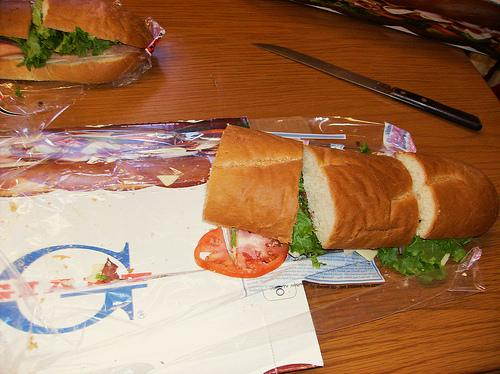In the product advertisement task, what products are shown in the image and how would you describe them for advertisement purposes? There are sandwiches or subs featuring fresh vegetables, like green lettuce and sliced tomatoes, as well as a high-quality, black handled kitchen knife on a stylish dark brown table. What type of packaging material is seen on the table? A blue and white plastic wrap, and a blue and white box or paper are seen on the table. Identify the primary object in the image and describe its appearance. The main object is a large sandwich on the table, which has slices of bread, tomatoes, green lettuce, and other ingredients. In the visual entailment task, describe the relation between the sandwich and the knife in the image. The knife may have been used to cut the sandwich into smaller slices, as bread appears to have been cut in the image. What type of food can you spot in the image? A sandwich or sub with green lettuce, sliced tomatoes, and various other fillings. What kind of surface does the scene take place on, and what is its color? The scene takes place on a dark brown table. In the multi-choice VQA task, what is the shape of the tomato slices in the image? The shape of the tomato slices is round. List three colors that can be seen on items in the image. Blue, white, and brown are colors visible on items in the image. Which kitchen tool is present on the table and what is its color? A knife with a black handle and sharp blade is present on the table. 